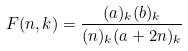<formula> <loc_0><loc_0><loc_500><loc_500>F ( n , k ) = \frac { ( a ) _ { k } ( b ) _ { k } } { ( n ) _ { k } ( a + 2 n ) _ { k } }</formula> 